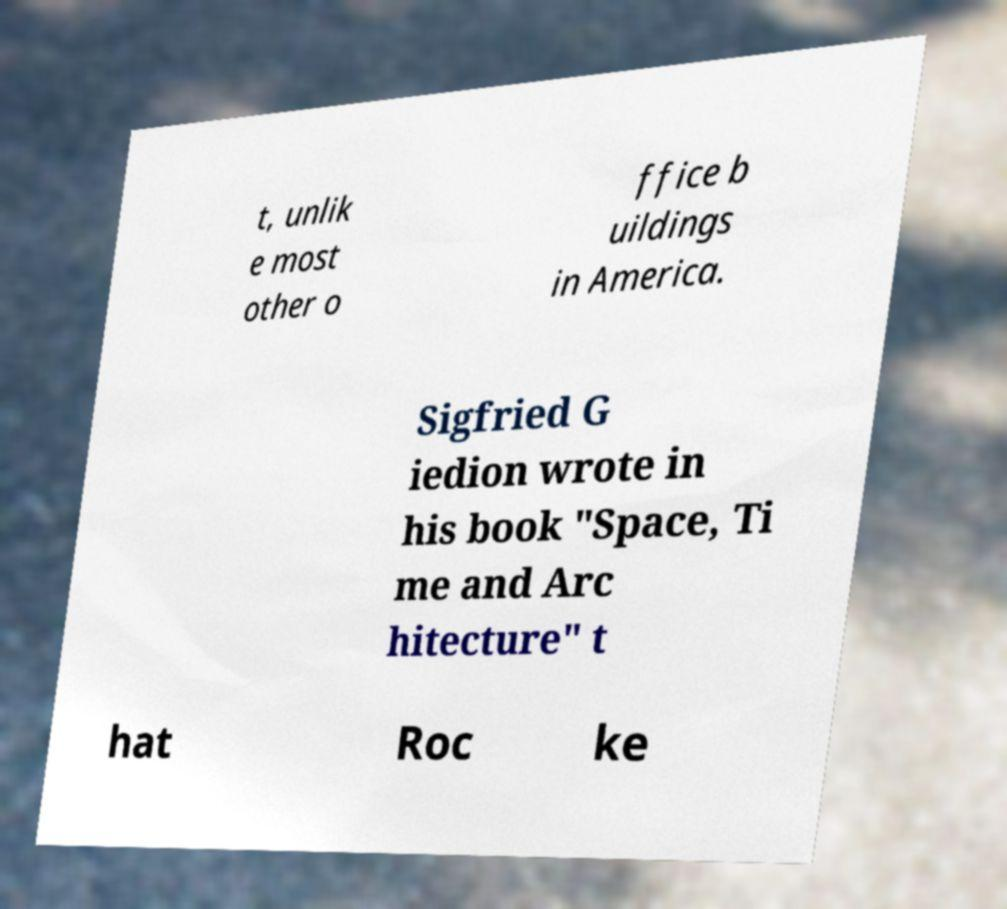What messages or text are displayed in this image? I need them in a readable, typed format. t, unlik e most other o ffice b uildings in America. Sigfried G iedion wrote in his book "Space, Ti me and Arc hitecture" t hat Roc ke 